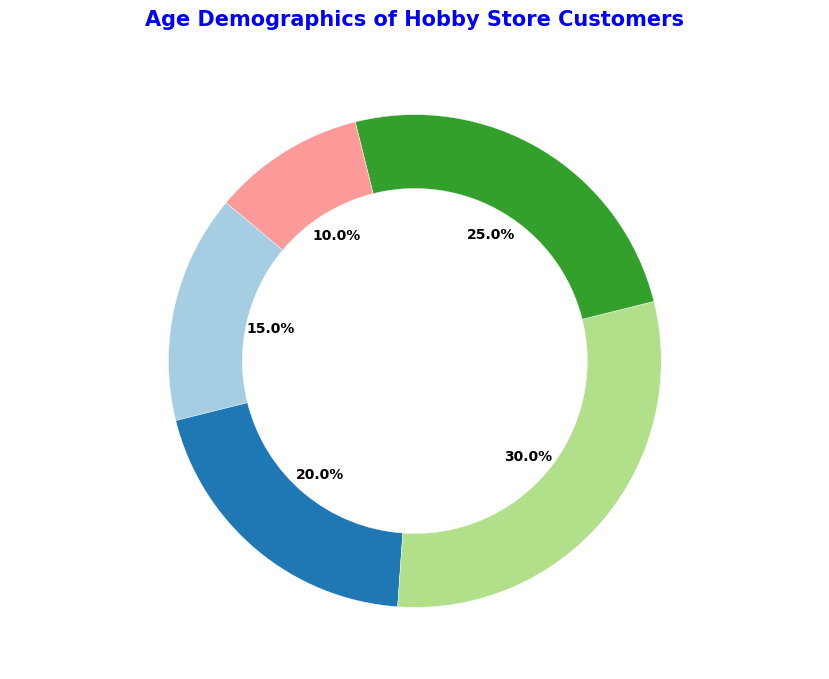What's the largest age group for hobby store customers? The pie chart shows various percentages of different age groups, and the largest percentage belongs to the "Young Adults" group which is 30%.
Answer: Young Adults (20-35) Which age group has the smallest percentage of customers? By glancing at the pie chart, the smallest section has the percentage mentioned for the "Seniors" group, which is 10%.
Answer: Seniors (56+) How many age groups have a percentage more than 20%? From the pie chart, identify the groups with percentages more than 20%: "Teenagers" (20%), "Young Adults" (30%), and "Middle-aged Adults" (25%). Both "Young Adults" and "Middle-aged Adults" surpass 20%, making it 2 groups.
Answer: 2 What is the combined percentage of "Teenagers" and "Middle-aged Adults"? Add the percentages of "Teenagers" (20%) and "Middle-aged Adults" (25%) from the pie chart: 20% + 25% = 45%.
Answer: 45% What's the color of the segment representing "Children"? By observing the pie chart, the segment for "Children" is in a distinguishable color. Identify this color visually.
Answer: Determine by color observation Which age group shares a similar segment size visually with "Middle-aged Adults"? Compare the pie chart sections visually to find the one close in size to "Middle-aged Adults" (25%). "Teenagers" (20%) have a comparable size.
Answer: Teenagers (13-19) How much is the difference in percentages between the largest and the smallest age groups? Subtract the smallest percentage (Seniors 10%) from the largest (Young Adults 30%): 30% - 10% = 20%.
Answer: 20% Which two age groups together constitute half of the total customer base? Look for two groups whose combined percentage is closest to 50%. "Young Adults" (30%) and "Middle-aged Adults" (25%) sum up to 55%, and any larger group pairs would exceed half.
Answer: Young Adults (20-35) and Middle-aged Adults (36-55) What's the average percentage of the five age groups listed? Sum all group percentages and divide by the count of groups: (15% + 20% + 30% + 25% + 10%) / 5 = 100% / 5 = 20%.
Answer: 20% What proportion of customers are adults (combining young adults and middle-aged adults)? Sum the proportions of "Young Adults" (30%) and "Middle-aged Adults" (25%): 30% + 25% = 55%.
Answer: 55% 